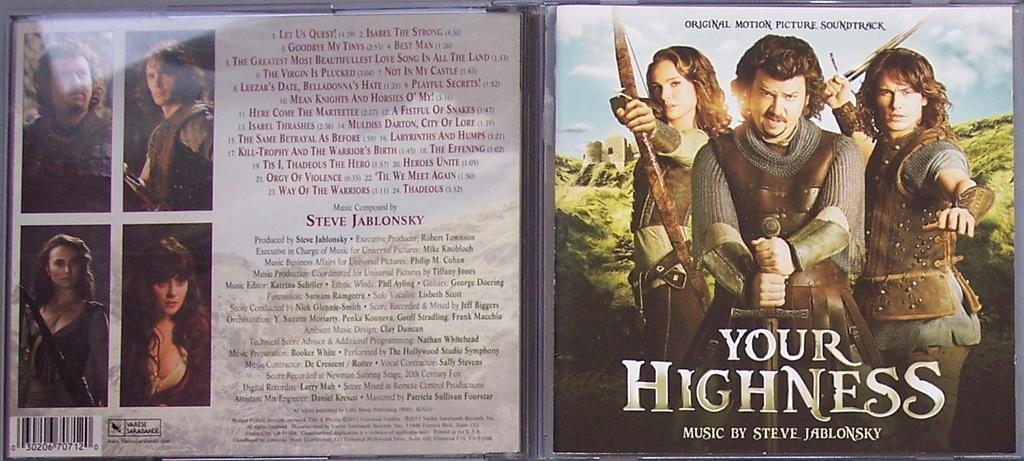<image>
Create a compact narrative representing the image presented. The music for this film was created by Steve Jablonsky. 